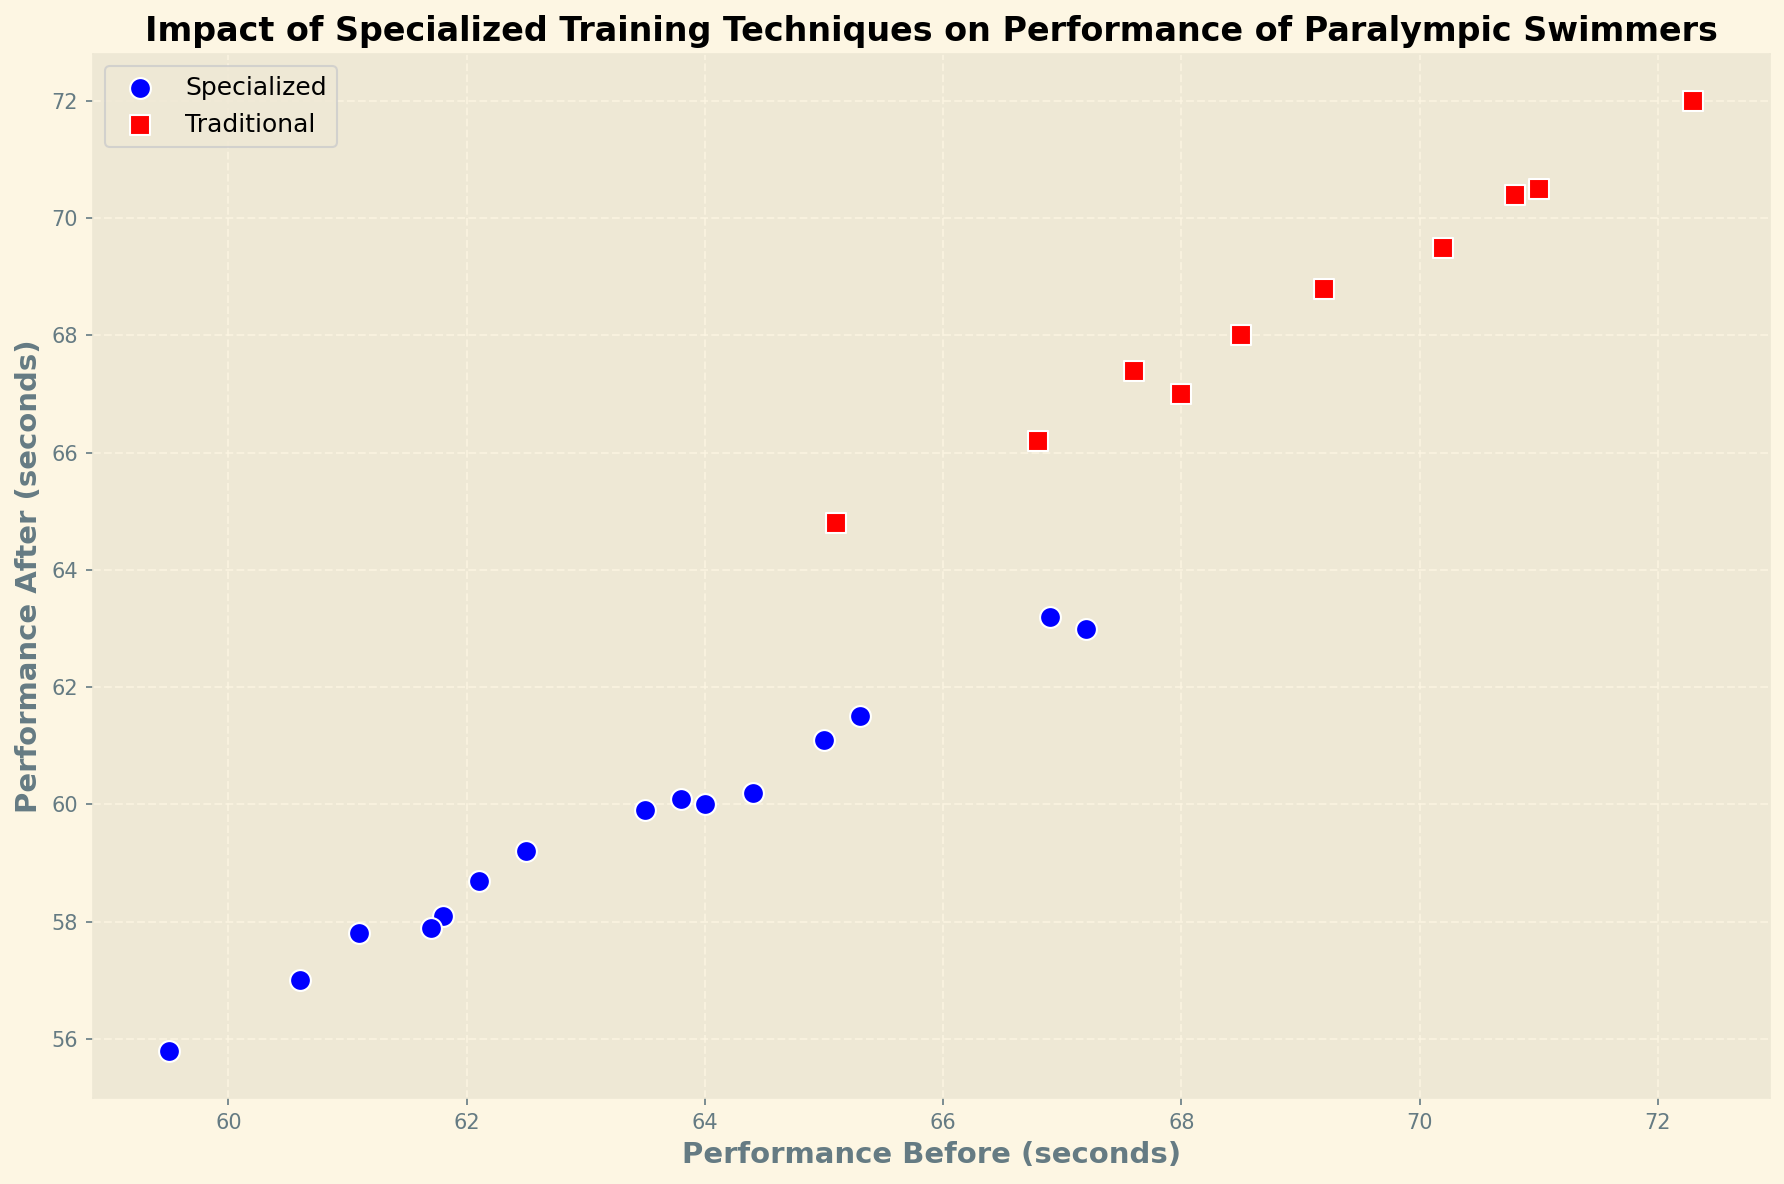Which training method resulted in the greatest improvement in performance for a swimmer? To determine this, look at the difference between 'Performance Before' and 'Performance After' for each swimmer. The greatest improvement will have the largest difference.
Answer: Specialized Which training method shows the most consistency in performance improvement? To determine this, look at the spread of points in the scatter plot for each group. If the points are closely packed, it indicates more consistency.
Answer: Specialized What is the average Performance After for swimmers using Specialized training methods? Calculate the average of 'Performance After' values for those using Specialized methods: (58.1 + 60.2 + 55.8 + 58.7 + 61.1 + 57.0 + 59.9 + 63.0 + 60.0 + 59.2 + 57.8 + 60.1 + 61.5 + 63.2 + 57.9) / 15.
Answer: 59.7 Which training method has a higher median value for Performance Before? Median is the middle value in a sorted list: Compare the median of 'Performance Before' for both Specialized and Traditional: Specialized values are 59.5, 60.6, 61.1, 61.7, 61.8, 62.1, 62.5, 63.5, 63.8, 64.0, 64.4, 65.0, 65.3, 66.9, 67.2. Traditional values are 65.1, 66.8, 67.6, 68.0, 68.5, 69.2, 70.2, 70.8, 71.0, 72.3. The median values are 63.5 and 68.35 respectively.
Answer: Traditional How does the best Traditional method performance compare to the best Specialized method performance after training? Compare the lowest 'Performance After' value for both methods: Specialized's best is 55.8 (Swimmer ID 4), Traditional's best is 64.8 (Swimmer ID 13).
Answer: Specialized method is better 